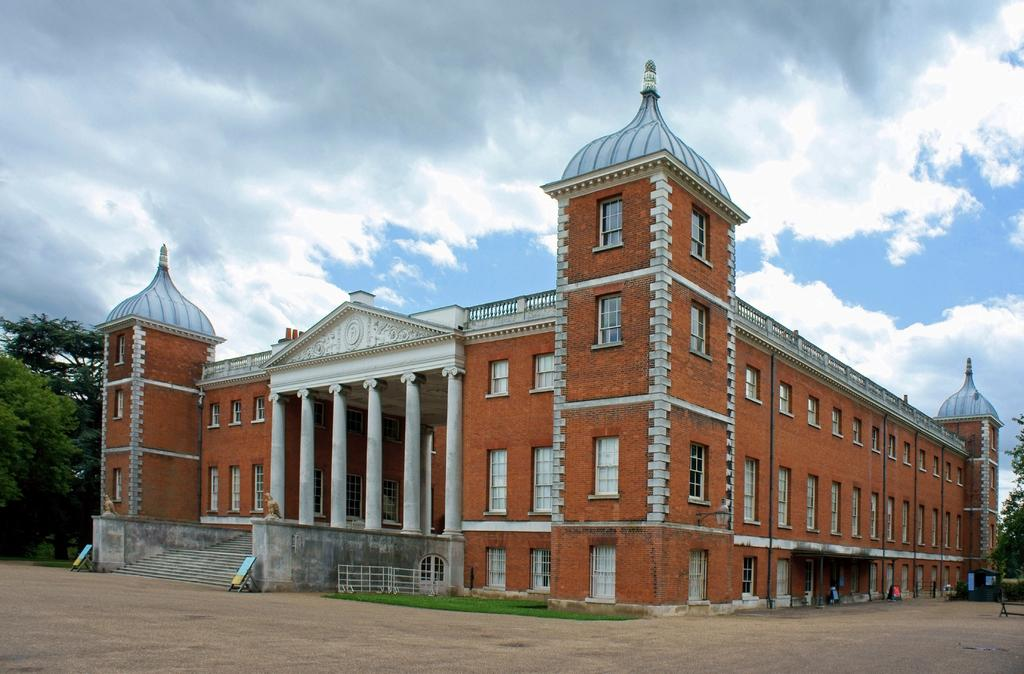What type of structure is present in the image? There is a building in the image. What is the color of the building? The building is brick-colored. Are there any natural elements present in the image? Yes, there are trees on either side of the building. How would you describe the sky in the image? The sky is cloudy. What type of engine can be seen powering the building in the image? There is no engine present in the image, as buildings do not require engines for operation. 